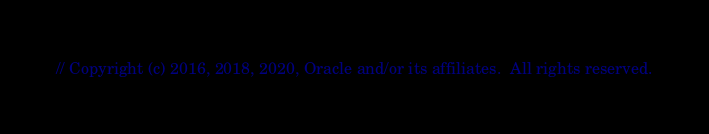<code> <loc_0><loc_0><loc_500><loc_500><_Go_>// Copyright (c) 2016, 2018, 2020, Oracle and/or its affiliates.  All rights reserved.</code> 